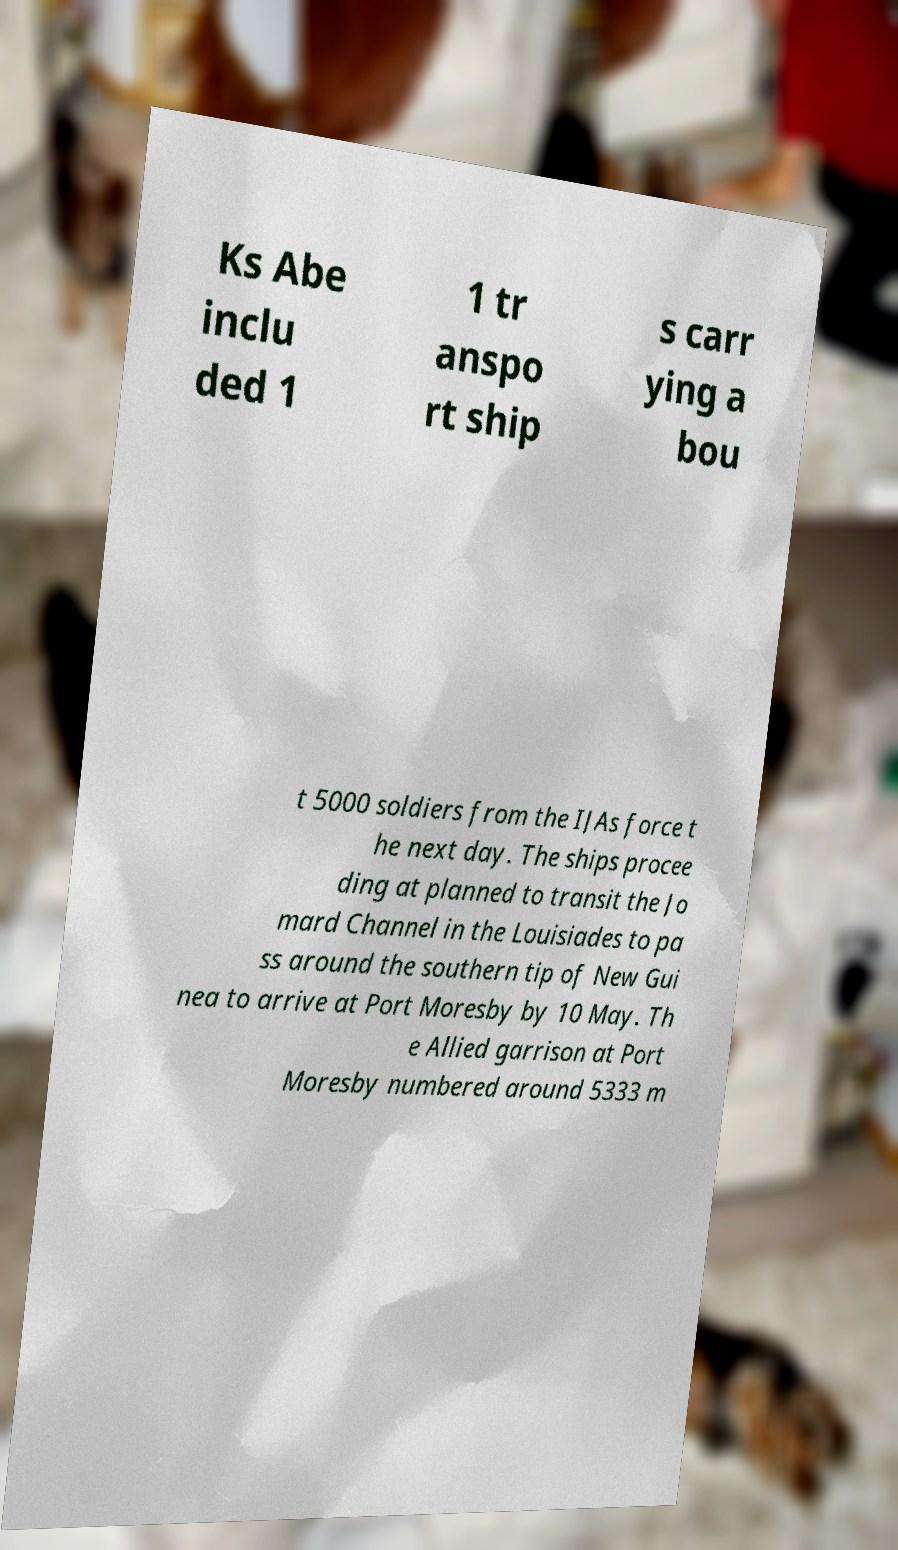What messages or text are displayed in this image? I need them in a readable, typed format. Ks Abe inclu ded 1 1 tr anspo rt ship s carr ying a bou t 5000 soldiers from the IJAs force t he next day. The ships procee ding at planned to transit the Jo mard Channel in the Louisiades to pa ss around the southern tip of New Gui nea to arrive at Port Moresby by 10 May. Th e Allied garrison at Port Moresby numbered around 5333 m 